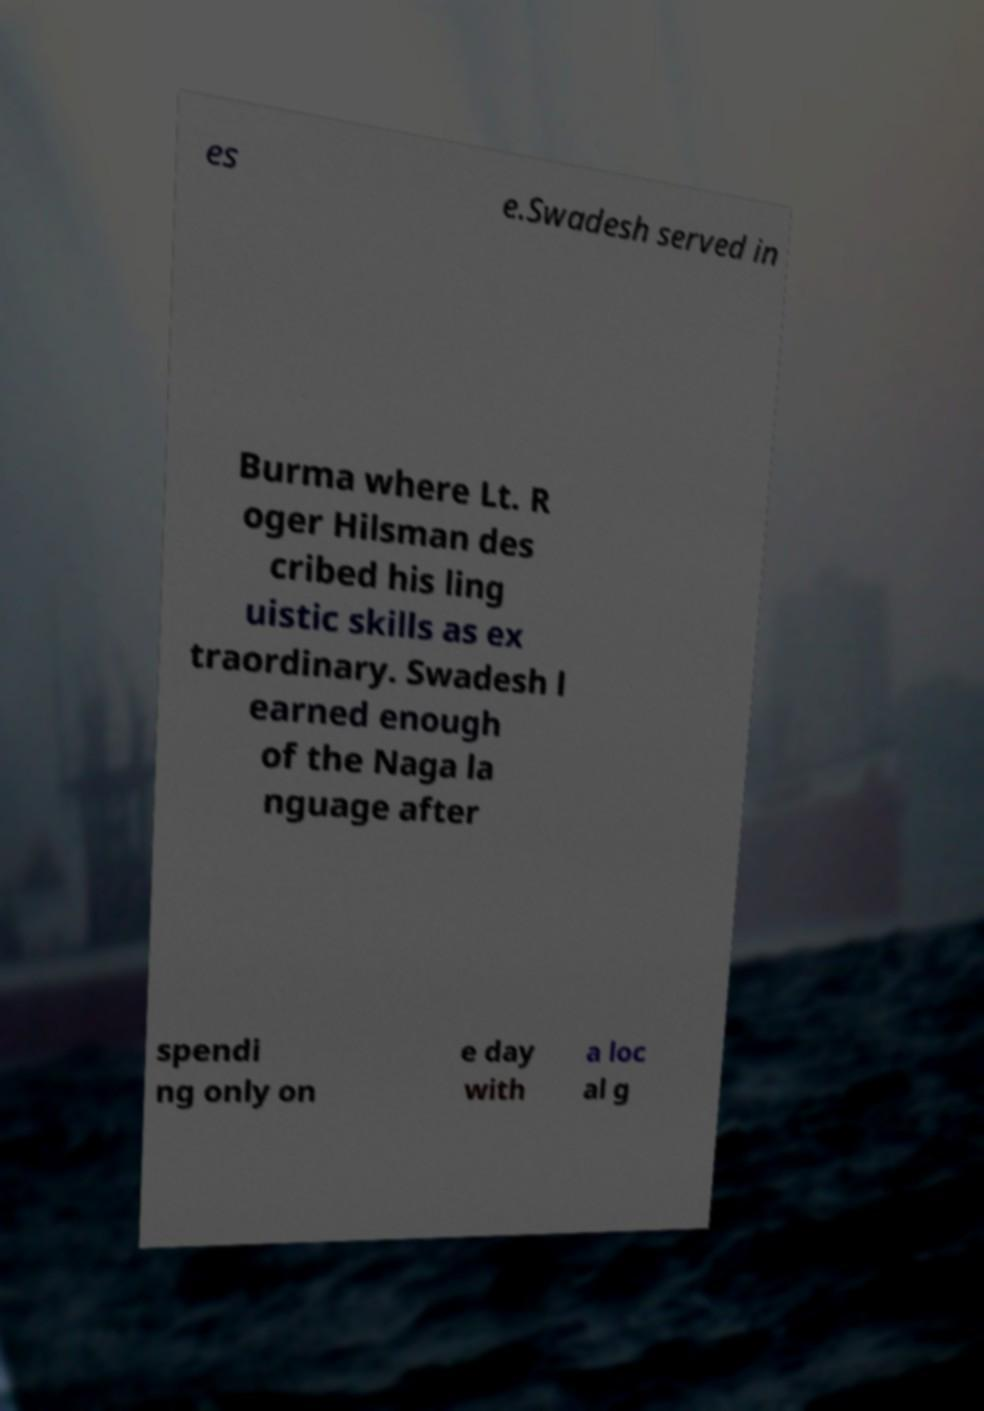Could you assist in decoding the text presented in this image and type it out clearly? es e.Swadesh served in Burma where Lt. R oger Hilsman des cribed his ling uistic skills as ex traordinary. Swadesh l earned enough of the Naga la nguage after spendi ng only on e day with a loc al g 